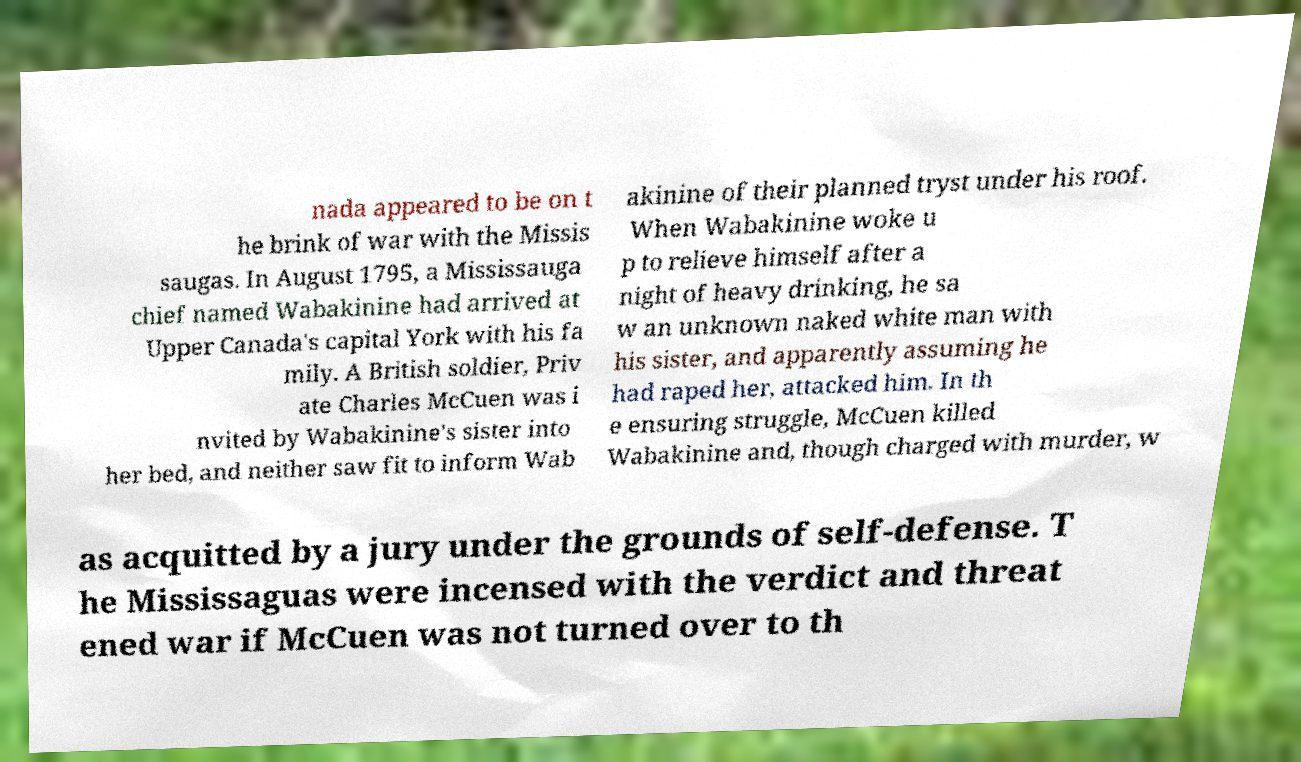For documentation purposes, I need the text within this image transcribed. Could you provide that? nada appeared to be on t he brink of war with the Missis saugas. In August 1795, a Mississauga chief named Wabakinine had arrived at Upper Canada's capital York with his fa mily. A British soldier, Priv ate Charles McCuen was i nvited by Wabakinine's sister into her bed, and neither saw fit to inform Wab akinine of their planned tryst under his roof. When Wabakinine woke u p to relieve himself after a night of heavy drinking, he sa w an unknown naked white man with his sister, and apparently assuming he had raped her, attacked him. In th e ensuring struggle, McCuen killed Wabakinine and, though charged with murder, w as acquitted by a jury under the grounds of self-defense. T he Mississaguas were incensed with the verdict and threat ened war if McCuen was not turned over to th 